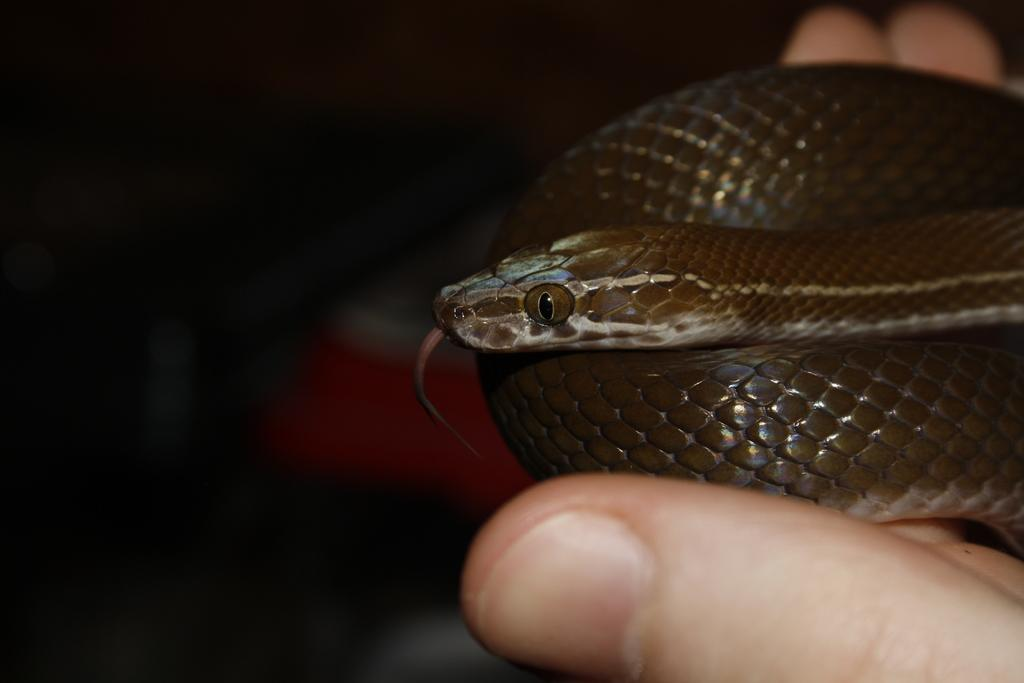What is the main subject of the image? There is a person in the image. What is the person holding in their hand? The person is holding a snake in their hand. On which side of the image is the snake located? The snake is on the right side of the image. What type of pickle is being used to play with the trucks in the image? There is no pickle or trucks present in the image; it features a person holding a snake. 